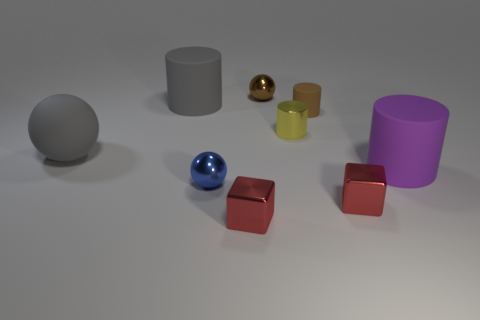Add 1 brown objects. How many objects exist? 10 Subtract all balls. How many objects are left? 6 Subtract 0 cyan spheres. How many objects are left? 9 Subtract all large gray shiny things. Subtract all large rubber objects. How many objects are left? 6 Add 9 blue shiny things. How many blue shiny things are left? 10 Add 7 tiny red blocks. How many tiny red blocks exist? 9 